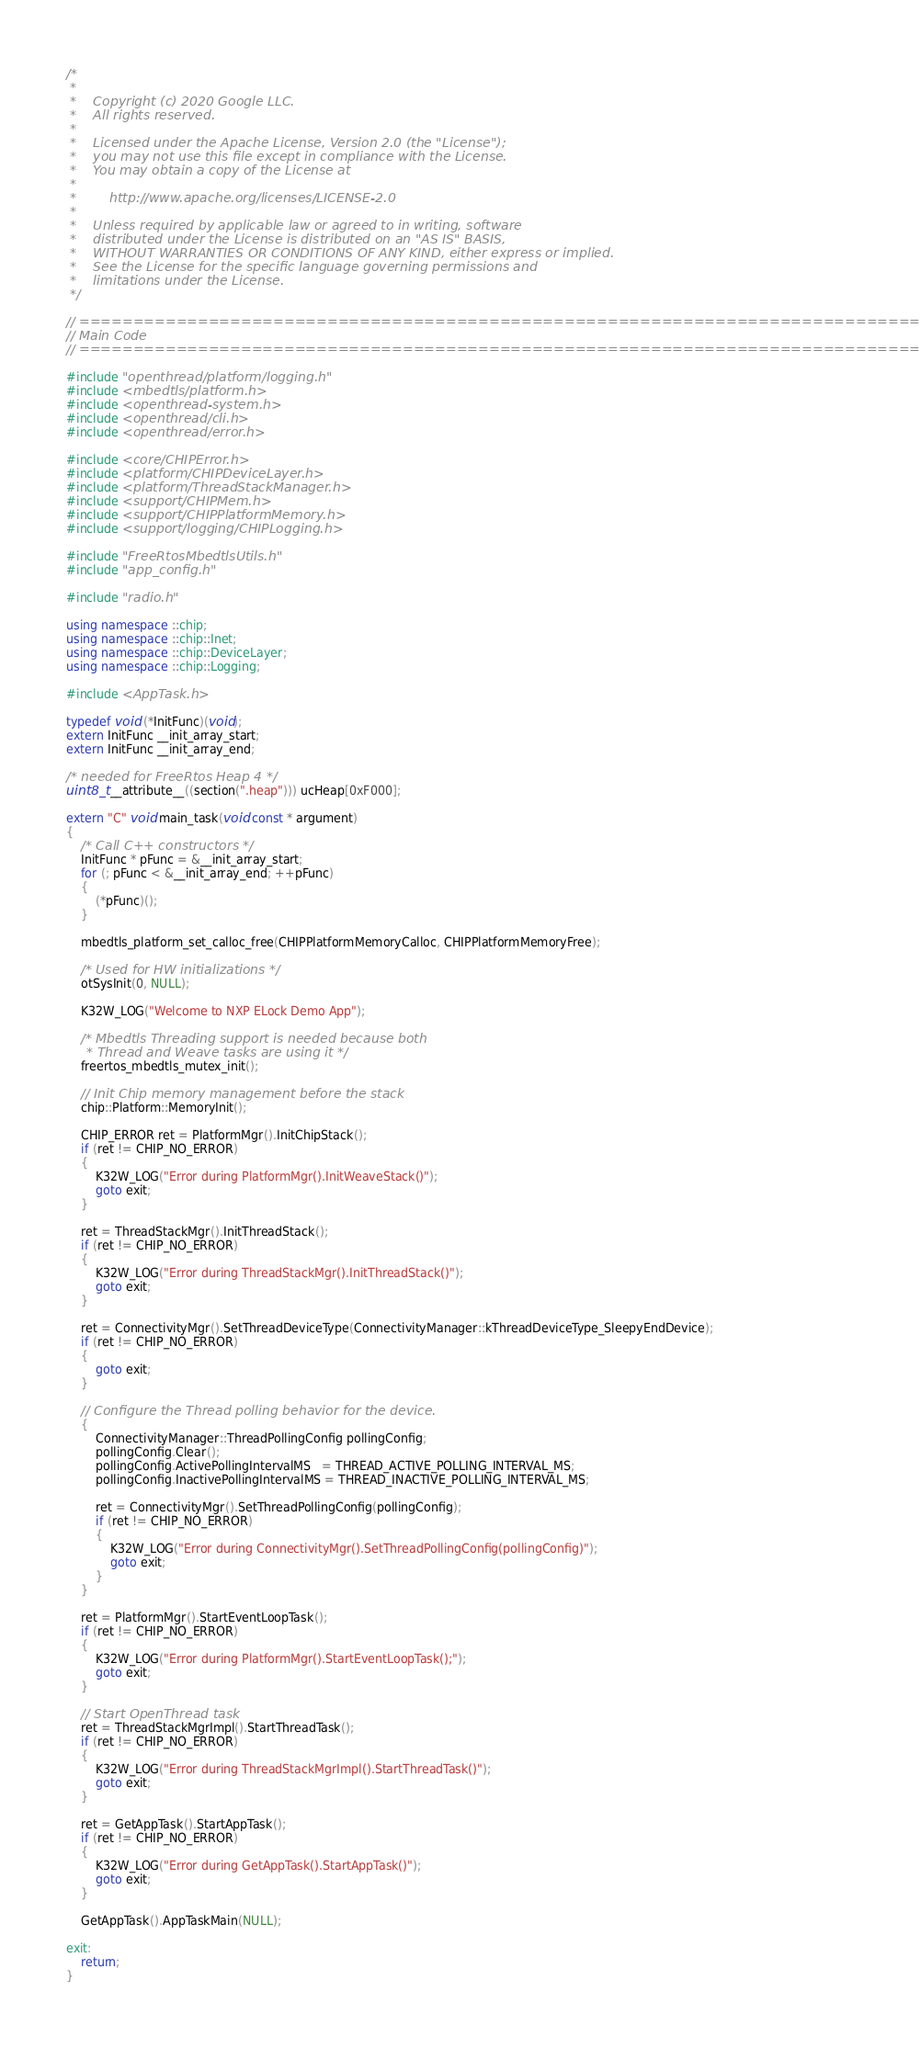Convert code to text. <code><loc_0><loc_0><loc_500><loc_500><_C++_>/*
 *
 *    Copyright (c) 2020 Google LLC.
 *    All rights reserved.
 *
 *    Licensed under the Apache License, Version 2.0 (the "License");
 *    you may not use this file except in compliance with the License.
 *    You may obtain a copy of the License at
 *
 *        http://www.apache.org/licenses/LICENSE-2.0
 *
 *    Unless required by applicable law or agreed to in writing, software
 *    distributed under the License is distributed on an "AS IS" BASIS,
 *    WITHOUT WARRANTIES OR CONDITIONS OF ANY KIND, either express or implied.
 *    See the License for the specific language governing permissions and
 *    limitations under the License.
 */

// ================================================================================
// Main Code
// ================================================================================

#include "openthread/platform/logging.h"
#include <mbedtls/platform.h>
#include <openthread-system.h>
#include <openthread/cli.h>
#include <openthread/error.h>

#include <core/CHIPError.h>
#include <platform/CHIPDeviceLayer.h>
#include <platform/ThreadStackManager.h>
#include <support/CHIPMem.h>
#include <support/CHIPPlatformMemory.h>
#include <support/logging/CHIPLogging.h>

#include "FreeRtosMbedtlsUtils.h"
#include "app_config.h"

#include "radio.h"

using namespace ::chip;
using namespace ::chip::Inet;
using namespace ::chip::DeviceLayer;
using namespace ::chip::Logging;

#include <AppTask.h>

typedef void (*InitFunc)(void);
extern InitFunc __init_array_start;
extern InitFunc __init_array_end;

/* needed for FreeRtos Heap 4 */
uint8_t __attribute__((section(".heap"))) ucHeap[0xF000];

extern "C" void main_task(void const * argument)
{
    /* Call C++ constructors */
    InitFunc * pFunc = &__init_array_start;
    for (; pFunc < &__init_array_end; ++pFunc)
    {
        (*pFunc)();
    }

    mbedtls_platform_set_calloc_free(CHIPPlatformMemoryCalloc, CHIPPlatformMemoryFree);

    /* Used for HW initializations */
    otSysInit(0, NULL);

    K32W_LOG("Welcome to NXP ELock Demo App");

    /* Mbedtls Threading support is needed because both
     * Thread and Weave tasks are using it */
    freertos_mbedtls_mutex_init();

    // Init Chip memory management before the stack
    chip::Platform::MemoryInit();

    CHIP_ERROR ret = PlatformMgr().InitChipStack();
    if (ret != CHIP_NO_ERROR)
    {
        K32W_LOG("Error during PlatformMgr().InitWeaveStack()");
        goto exit;
    }

    ret = ThreadStackMgr().InitThreadStack();
    if (ret != CHIP_NO_ERROR)
    {
        K32W_LOG("Error during ThreadStackMgr().InitThreadStack()");
        goto exit;
    }

    ret = ConnectivityMgr().SetThreadDeviceType(ConnectivityManager::kThreadDeviceType_SleepyEndDevice);
    if (ret != CHIP_NO_ERROR)
    {
        goto exit;
    }

    // Configure the Thread polling behavior for the device.
    {
        ConnectivityManager::ThreadPollingConfig pollingConfig;
        pollingConfig.Clear();
        pollingConfig.ActivePollingIntervalMS   = THREAD_ACTIVE_POLLING_INTERVAL_MS;
        pollingConfig.InactivePollingIntervalMS = THREAD_INACTIVE_POLLING_INTERVAL_MS;

        ret = ConnectivityMgr().SetThreadPollingConfig(pollingConfig);
        if (ret != CHIP_NO_ERROR)
        {
            K32W_LOG("Error during ConnectivityMgr().SetThreadPollingConfig(pollingConfig)");
            goto exit;
        }
    }

    ret = PlatformMgr().StartEventLoopTask();
    if (ret != CHIP_NO_ERROR)
    {
        K32W_LOG("Error during PlatformMgr().StartEventLoopTask();");
        goto exit;
    }

    // Start OpenThread task
    ret = ThreadStackMgrImpl().StartThreadTask();
    if (ret != CHIP_NO_ERROR)
    {
        K32W_LOG("Error during ThreadStackMgrImpl().StartThreadTask()");
        goto exit;
    }

    ret = GetAppTask().StartAppTask();
    if (ret != CHIP_NO_ERROR)
    {
        K32W_LOG("Error during GetAppTask().StartAppTask()");
        goto exit;
    }

    GetAppTask().AppTaskMain(NULL);

exit:
    return;
}
</code> 